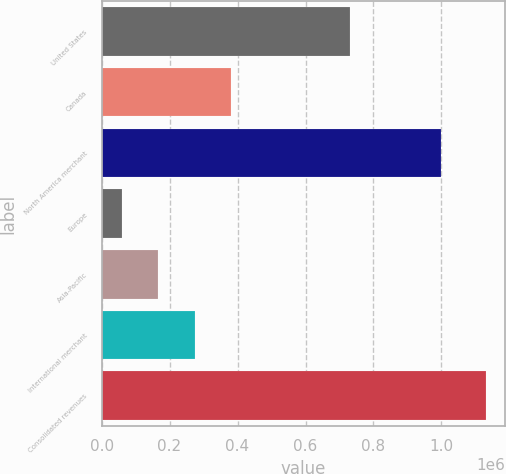Convert chart. <chart><loc_0><loc_0><loc_500><loc_500><bar_chart><fcel>United States<fcel>Canada<fcel>North America merchant<fcel>Europe<fcel>Asia-Pacific<fcel>International merchant<fcel>Consolidated revenues<nl><fcel>731214<fcel>381027<fcel>998463<fcel>59778<fcel>166861<fcel>273944<fcel>1.13061e+06<nl></chart> 